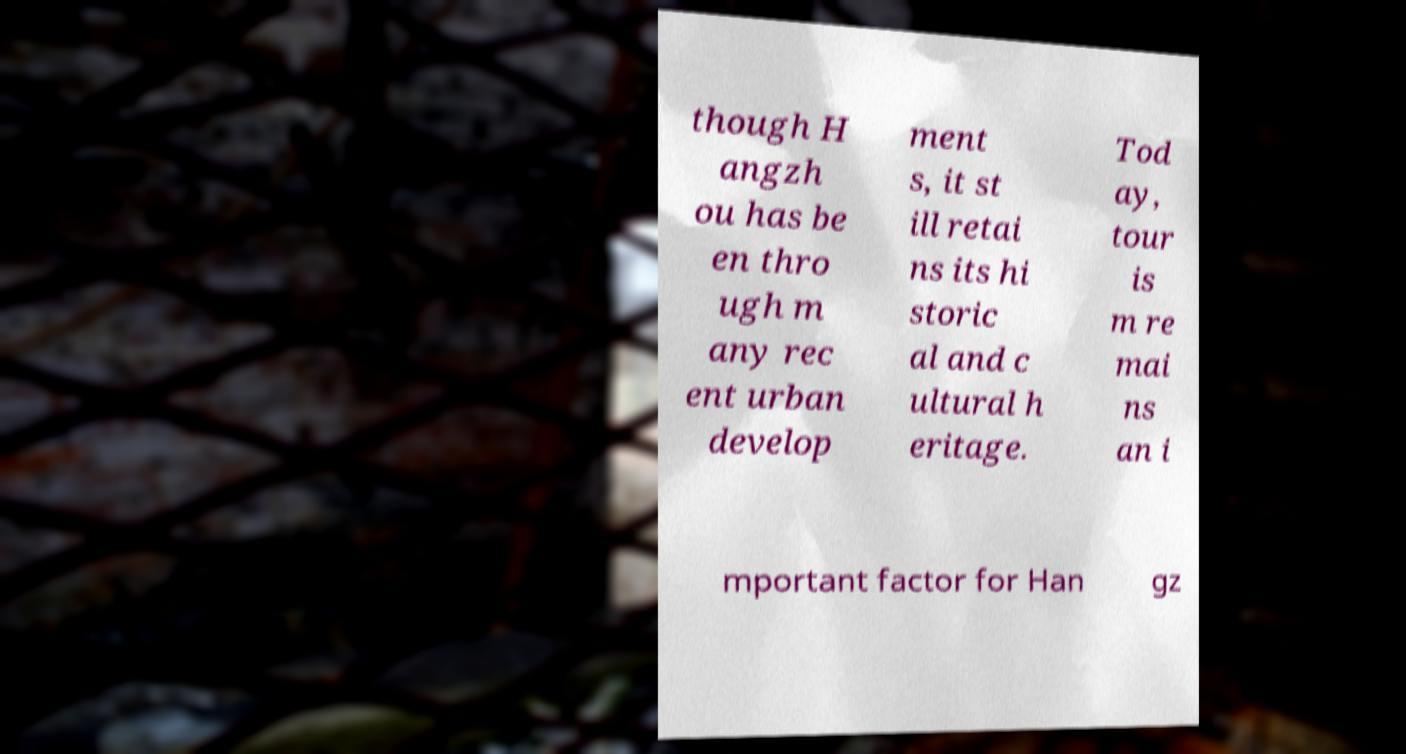Please identify and transcribe the text found in this image. though H angzh ou has be en thro ugh m any rec ent urban develop ment s, it st ill retai ns its hi storic al and c ultural h eritage. Tod ay, tour is m re mai ns an i mportant factor for Han gz 